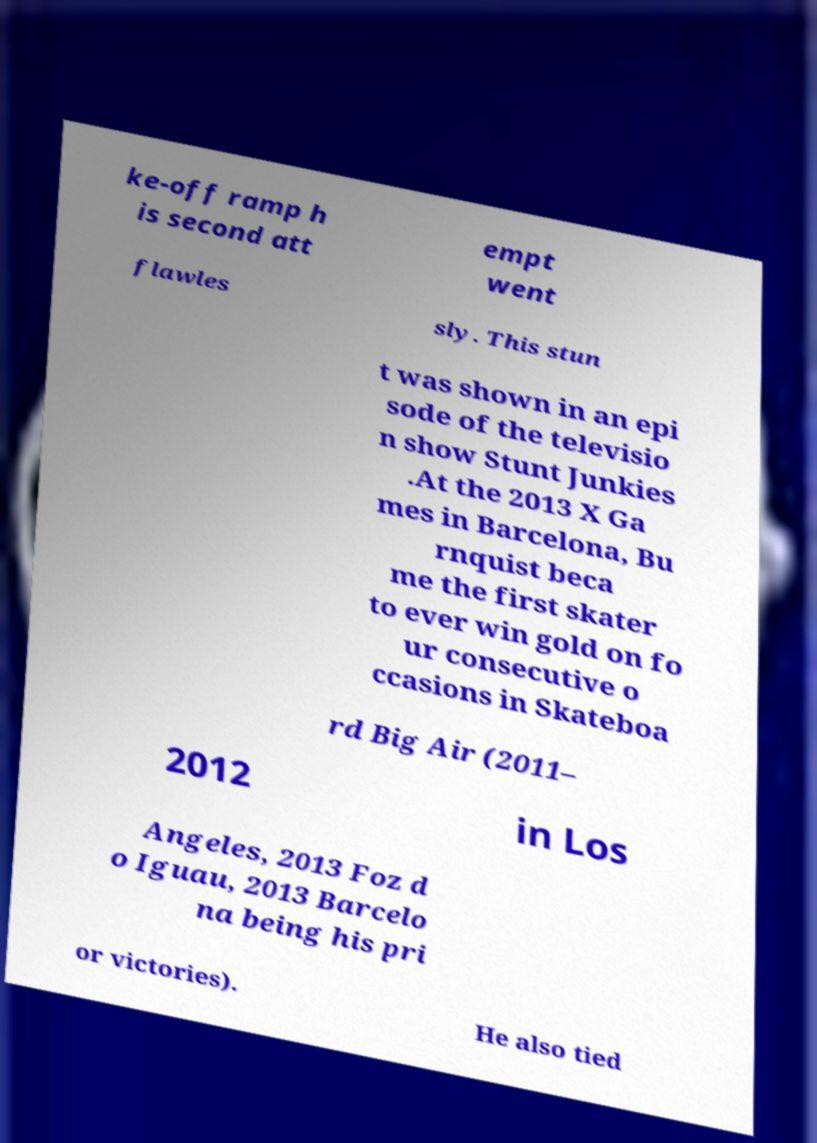There's text embedded in this image that I need extracted. Can you transcribe it verbatim? ke-off ramp h is second att empt went flawles sly. This stun t was shown in an epi sode of the televisio n show Stunt Junkies .At the 2013 X Ga mes in Barcelona, Bu rnquist beca me the first skater to ever win gold on fo ur consecutive o ccasions in Skateboa rd Big Air (2011– 2012 in Los Angeles, 2013 Foz d o Iguau, 2013 Barcelo na being his pri or victories). He also tied 